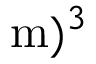Convert formula to latex. <formula><loc_0><loc_0><loc_500><loc_500>m ) ^ { 3 }</formula> 